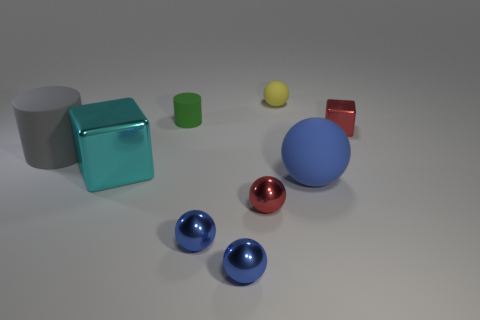There is a shiny block on the left side of the metal cube right of the small rubber cylinder; what color is it? cyan 